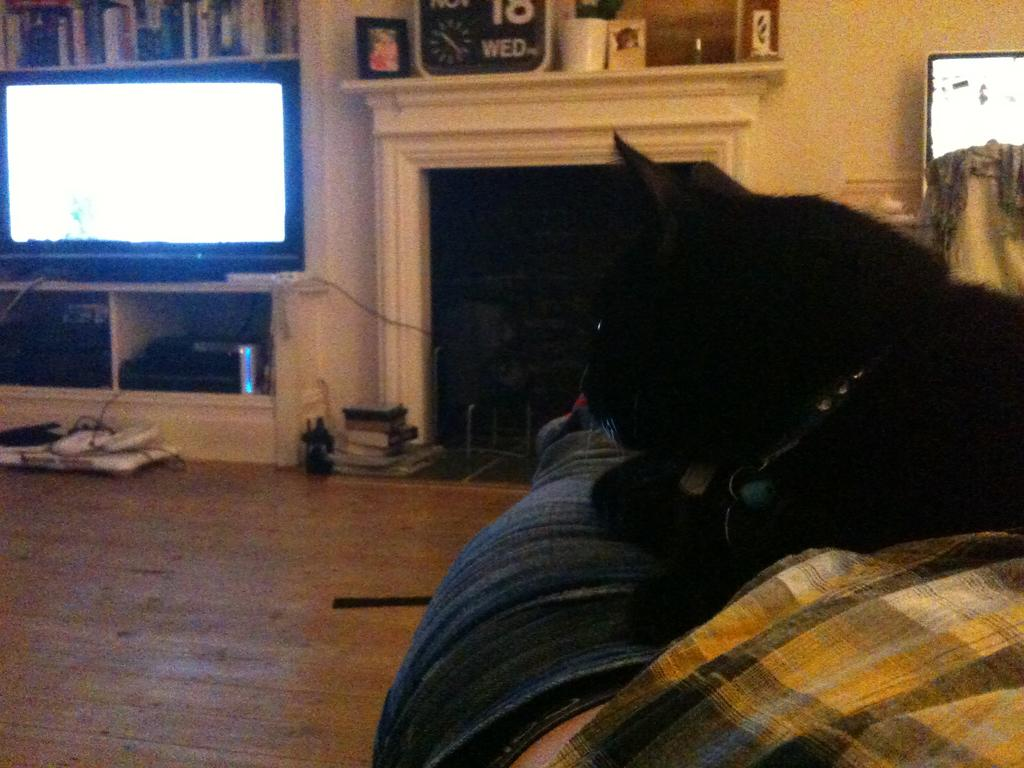What type of animal is in the image? There is a black animal in the image. What is the animal doing? The animal is sitting. What can be seen in the background of the image? There is a television, a fireplace, a photo frame, and a clock in the background of the image. What type of flowers are on the table in the image? There are no flowers present in the image. 